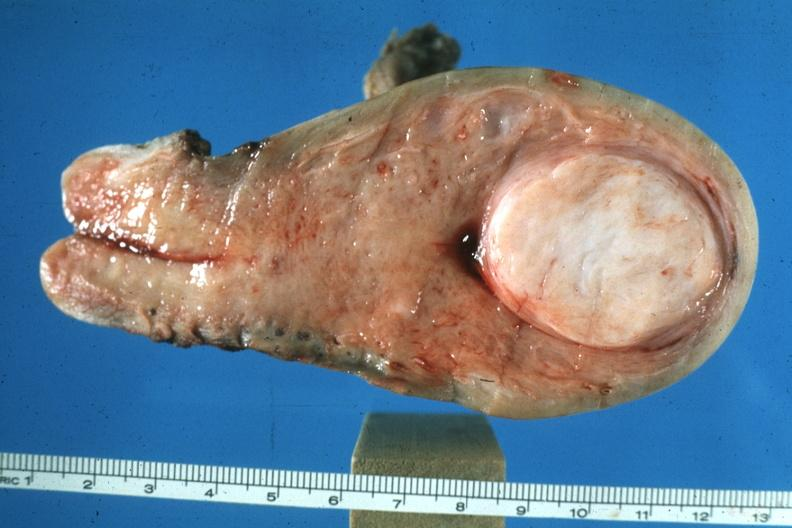s female reproductive present?
Answer the question using a single word or phrase. Yes 